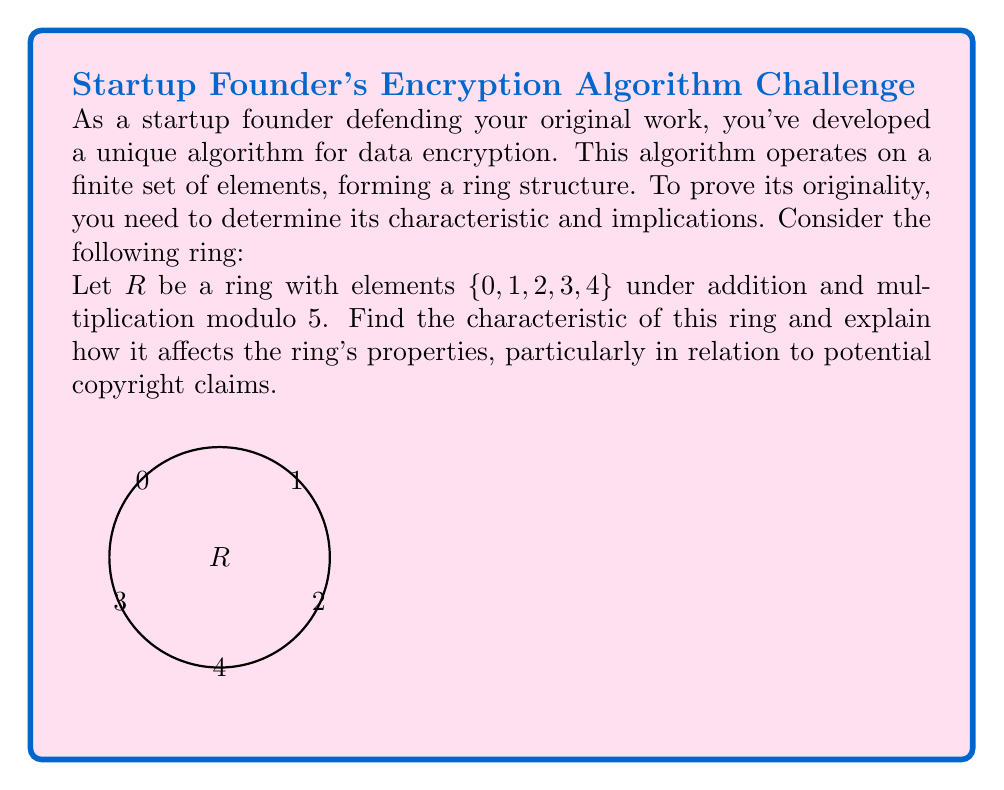Show me your answer to this math problem. To find the characteristic of the ring $R$ and understand its implications, let's follow these steps:

1) The characteristic of a ring is the smallest positive integer $n$ such that $n \cdot a = 0$ for all elements $a$ in the ring. If no such integer exists, the characteristic is 0.

2) In this case, we need to check for each element:

   $5 \cdot 0 \equiv 0 \pmod{5}$
   $5 \cdot 1 \equiv 0 \pmod{5}$
   $5 \cdot 2 \equiv 0 \pmod{5}$
   $5 \cdot 3 \equiv 0 \pmod{5}$
   $5 \cdot 4 \equiv 0 \pmod{5}$

3) We see that 5 is the smallest positive integer that, when multiplied by any element in the ring, results in 0 (modulo 5).

4) Therefore, the characteristic of the ring $R$ is 5.

5) Implications of characteristic 5:

   a) The ring is a finite field, specifically $\mathbb{Z}_5$.
   b) Every element in the ring satisfies the equation $x^5 = x$ (Fermat's Little Theorem).
   c) The ring has no zero divisors other than 0.
   d) The ring is commutative.

6) In terms of copyright claims:
   - The characteristic being a prime number (5) implies that the ring has a unique structure that cannot be derived from simpler rings.
   - This uniqueness could potentially strengthen the argument for the originality of the encryption algorithm.
   - However, since $\mathbb{Z}_5$ is a well-known mathematical structure, the use of this specific ring alone may not be sufficient to claim complete originality.
Answer: Characteristic: 5. Implications: finite field, $x^5 = x$ for all $x$, no zero divisors, commutative. 